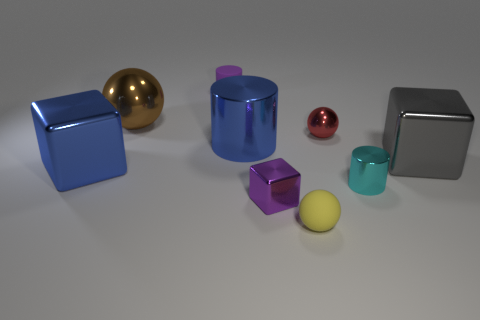Subtract all red spheres. Subtract all green cylinders. How many spheres are left? 2 Add 1 large yellow cubes. How many objects exist? 10 Subtract all cylinders. How many objects are left? 6 Add 3 big metallic spheres. How many big metallic spheres exist? 4 Subtract 0 gray cylinders. How many objects are left? 9 Subtract all matte things. Subtract all tiny cyan metallic cylinders. How many objects are left? 6 Add 9 cyan metal cylinders. How many cyan metal cylinders are left? 10 